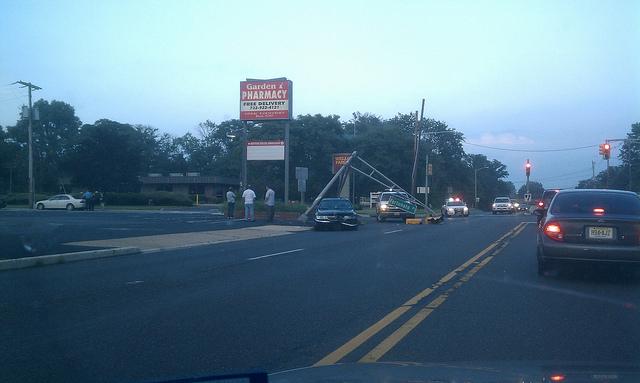What did the car hit?
Write a very short answer. Street light. Was there a wreck?
Be succinct. Yes. Is the driver stopping?
Answer briefly. Yes. Where is the silver car?
Be succinct. Road. How many red vehicles are on the street?
Answer briefly. 0. Is traffic moving?
Concise answer only. No. How many police cars are there?
Concise answer only. 1. Could traffic continue through the intersection?
Answer briefly. No. What color is traffic light in the back?
Give a very brief answer. Red. Is it going to rain?
Write a very short answer. Yes. 